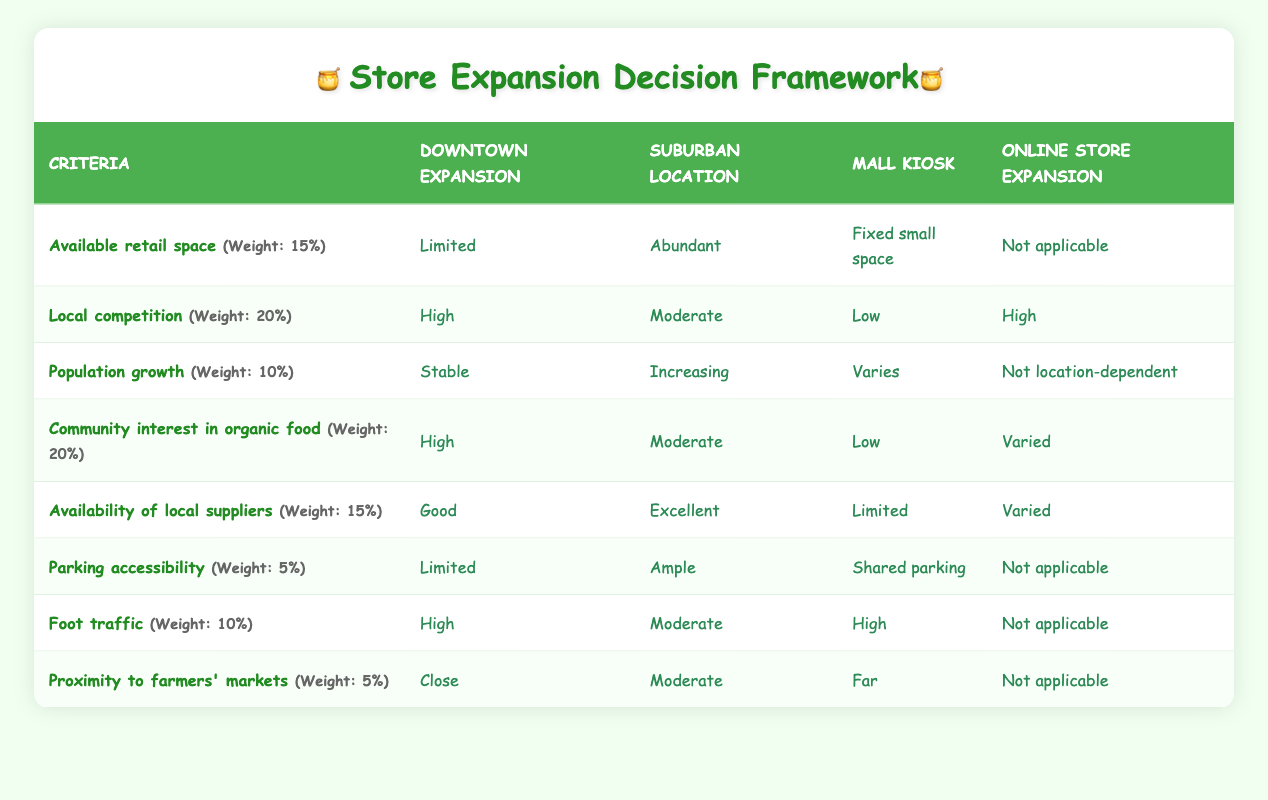What is the available retail space for suburban location? According to the table, the available retail space for the suburban location is categorized as "Abundant." This can be found in the first row under "Suburban location."
Answer: Abundant Which expansion option has the highest local competition? The table indicates that the downtown expansion has "High" local competition, more than any other option listed. This is found in the row for local competition under downtown expansion.
Answer: Downtown expansion How many expansion options have limited parking accessibility? The table shows that both downtown expansion and mall kiosk have limited parking accessibility. One is listed as "Limited" and the other as "Shared parking," which entails limited options for parking as well. Thus, there are two options with limited accessibility.
Answer: Two What is the average community interest in organic food for all expansion options? To find the average community interest, convert the ratings into a numerical score: High = 3, Moderate = 2, Low = 1, and Varied = 2 for online. Then, sum up the ratings: (3 + 2 + 1 + 2) = 8. There are four options, so the average is 8 / 4 = 2. This corresponds to a Moderate interest level.
Answer: Moderate Is there ample parking accessibility for the mall kiosk expansion? The table shows that the parking accessibility for the mall kiosk is listed as "Shared parking," which implies it is limited rather than ample. A comparison with the suburban location (which has ample) makes this clear.
Answer: No Which expansion option has the least availability of local suppliers? The mall kiosk option has "Limited" availability of local suppliers, which is the least of all categories compared to good, excellent, and varied options for others. This can be directly identified from the availability of local suppliers row.
Answer: Mall kiosk If you wanted the option with both high foot traffic and proximity to farmers' markets, which would you choose? High foot traffic is associated with both the downtown expansion and the mall kiosk. However, only downtown expansion is also "Close" to farmers' markets, making it the best choice. So, only one option fits both criteria.
Answer: Downtown expansion Which expansion option is best for population growth? The suburban location is experiencing "Increasing" population growth, which is more favorable than the other options, such as stable or not dependent on location. This is as per the row under population growth.
Answer: Suburban location 